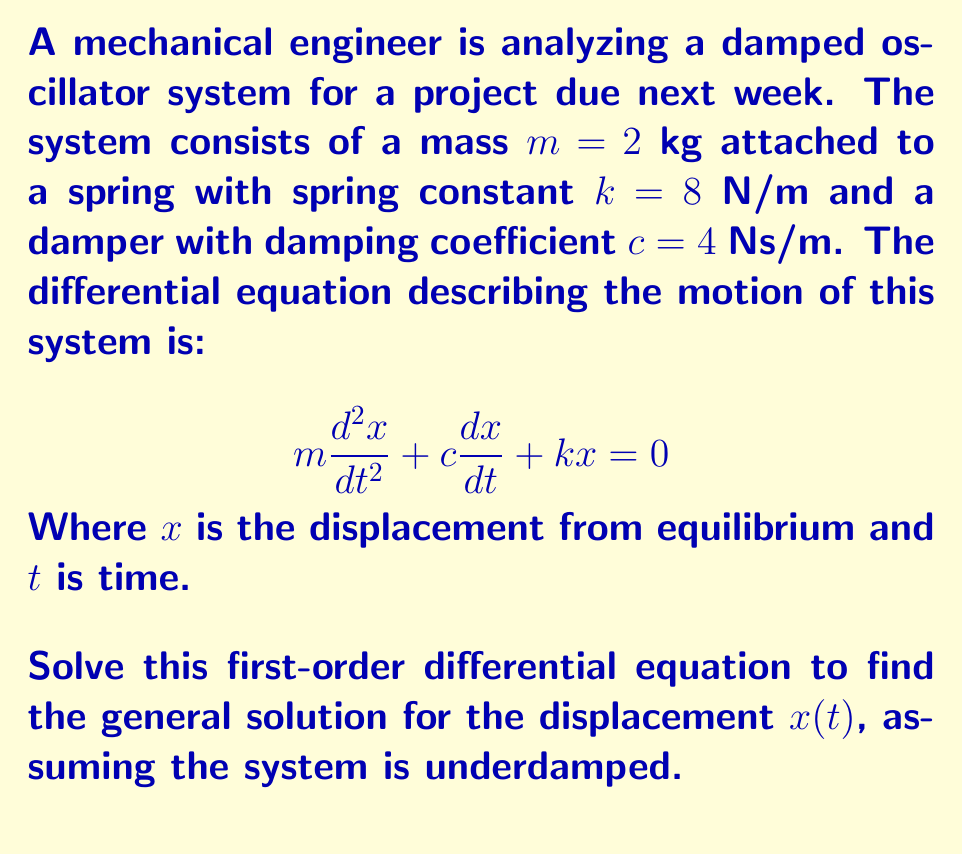Can you answer this question? Let's solve this step-by-step:

1) First, we need to determine if the system is underdamped. The condition for an underdamped system is:

   $$c^2 < 4mk$$

   Substituting the given values:
   $4^2 < 4(2)(8)$
   $16 < 64$

   This confirms that the system is indeed underdamped.

2) For an underdamped system, the general solution has the form:

   $$x(t) = e^{-\zeta\omega_n t}(A\cos(\omega_d t) + B\sin(\omega_d t))$$

   Where:
   - $\zeta$ is the damping ratio
   - $\omega_n$ is the natural frequency
   - $\omega_d$ is the damped natural frequency
   - $A$ and $B$ are constants determined by initial conditions

3) Calculate the natural frequency $\omega_n$:

   $$\omega_n = \sqrt{\frac{k}{m}} = \sqrt{\frac{8}{2}} = 2 \text{ rad/s}$$

4) Calculate the damping ratio $\zeta$:

   $$\zeta = \frac{c}{2m\omega_n} = \frac{4}{2(2)(2)} = 0.5$$

5) Calculate the damped natural frequency $\omega_d$:

   $$\omega_d = \omega_n\sqrt{1-\zeta^2} = 2\sqrt{1-0.5^2} = \sqrt{3} \text{ rad/s}$$

6) Substituting these values into the general solution:

   $$x(t) = e^{-t}(A\cos(\sqrt{3}t) + B\sin(\sqrt{3}t))$$

This is the general solution for the displacement $x(t)$. The constants $A$ and $B$ would be determined by the initial conditions, which are not provided in this problem.
Answer: $x(t) = e^{-t}(A\cos(\sqrt{3}t) + B\sin(\sqrt{3}t))$ 